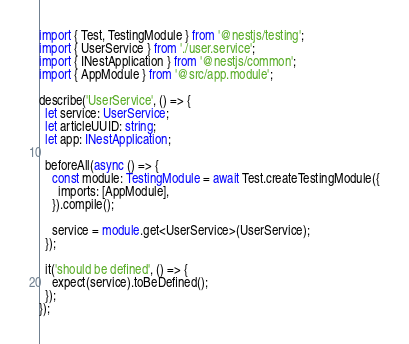Convert code to text. <code><loc_0><loc_0><loc_500><loc_500><_TypeScript_>import { Test, TestingModule } from '@nestjs/testing';
import { UserService } from './user.service';
import { INestApplication } from '@nestjs/common';
import { AppModule } from '@src/app.module';

describe('UserService', () => {
  let service: UserService;
  let articleUUID: string;
  let app: INestApplication;

  beforeAll(async () => {
    const module: TestingModule = await Test.createTestingModule({
      imports: [AppModule],
    }).compile();

    service = module.get<UserService>(UserService);
  });

  it('should be defined', () => {
    expect(service).toBeDefined();
  });
});
</code> 